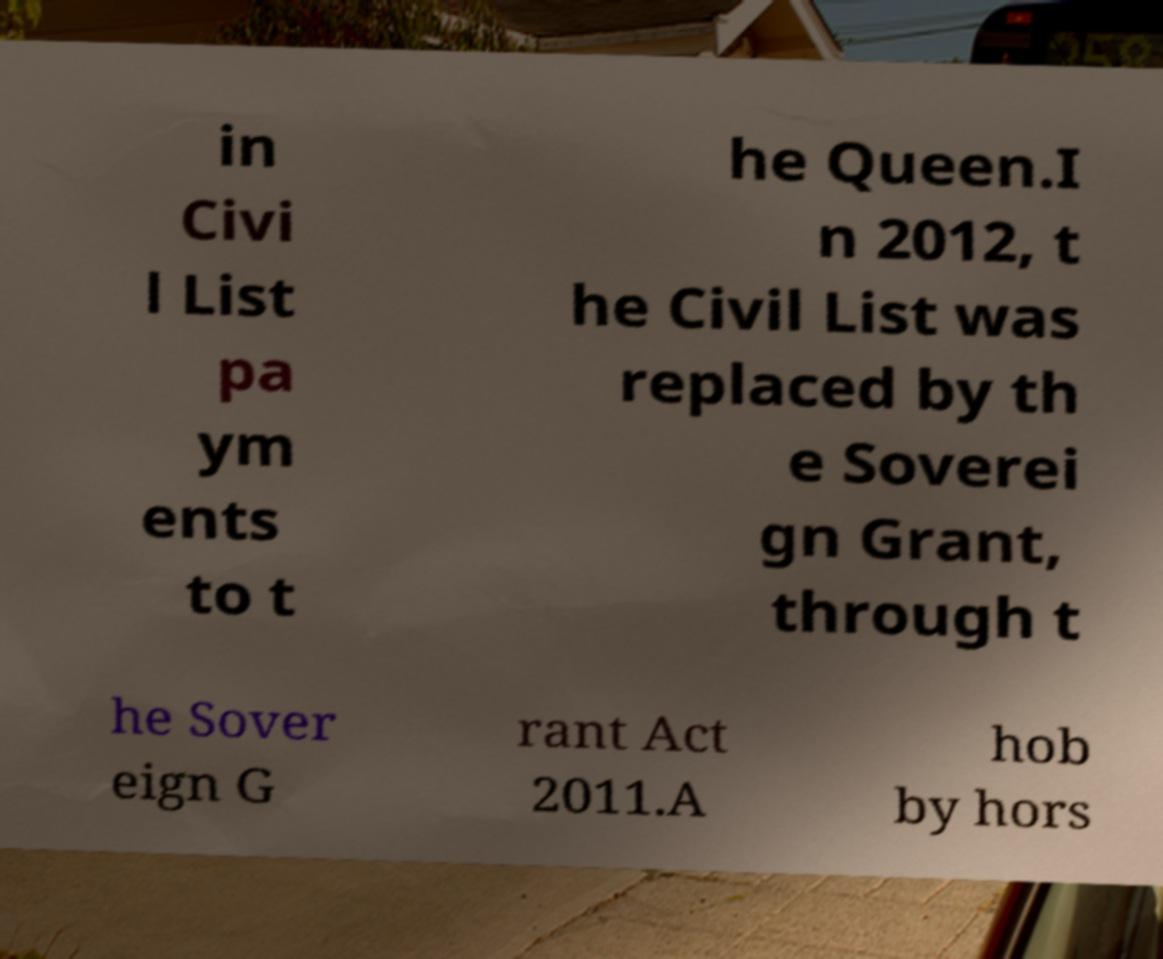Could you extract and type out the text from this image? in Civi l List pa ym ents to t he Queen.I n 2012, t he Civil List was replaced by th e Soverei gn Grant, through t he Sover eign G rant Act 2011.A hob by hors 